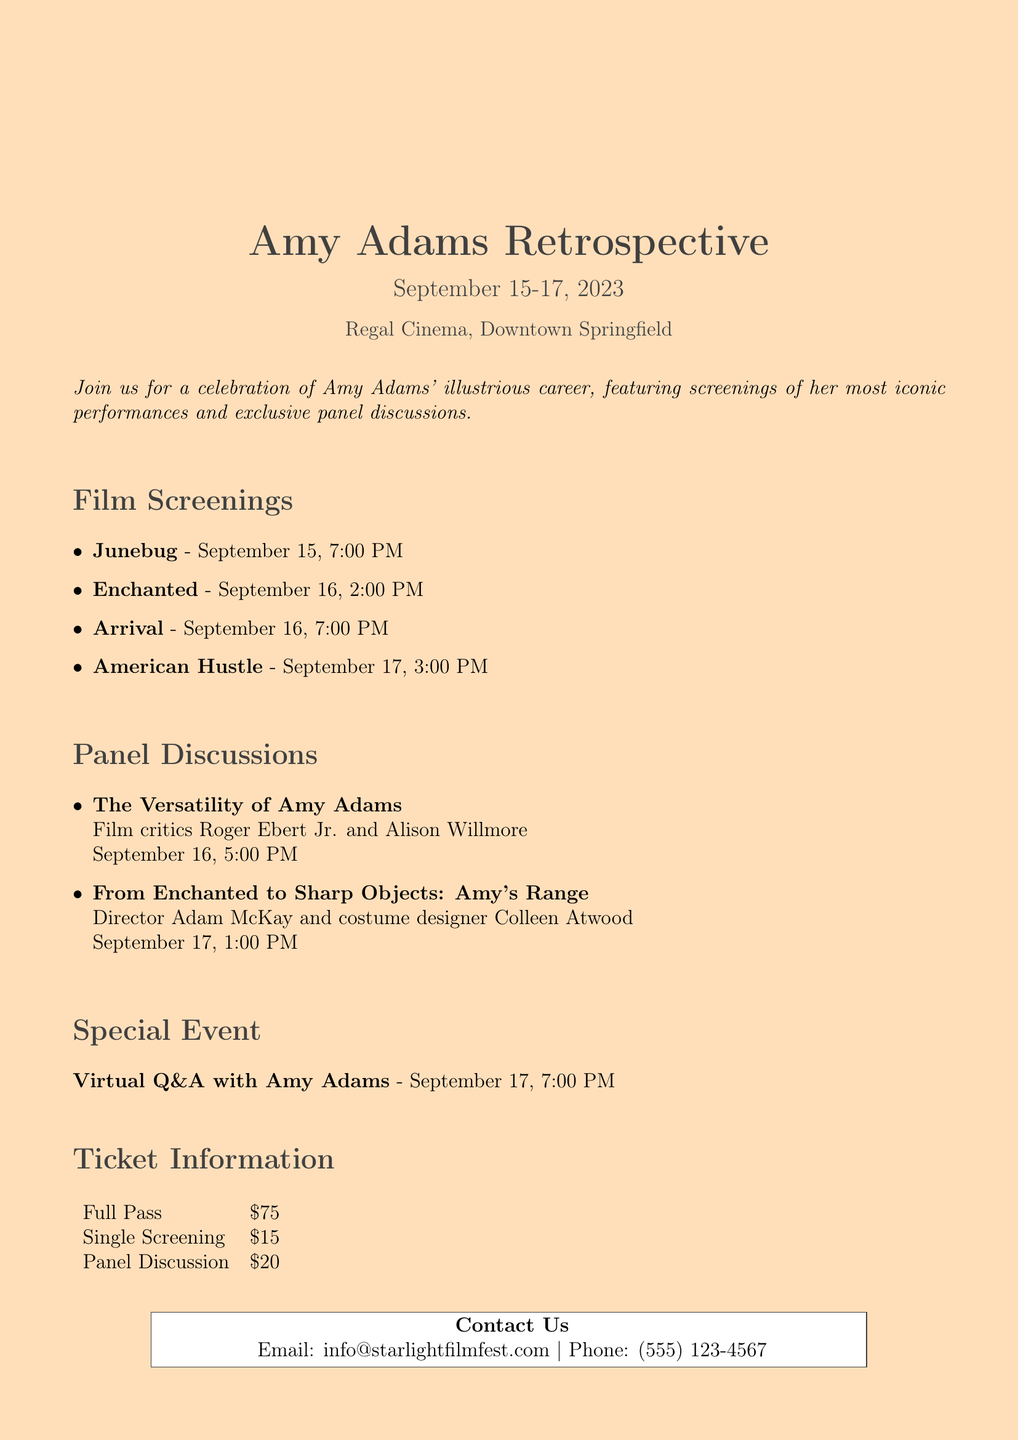What is the name of the event? The name of the event is mentioned at the beginning of the document as "Starlight Film Festival: Amy Adams Retrospective."
Answer: Starlight Film Festival: Amy Adams Retrospective What are the dates of the film festival? The dates of the film festival are clearly stated in the document as "September 15-17, 2023."
Answer: September 15-17, 2023 Where is the festival taking place? The document specifies the location as "Regal Cinema, Downtown Springfield."
Answer: Regal Cinema, Downtown Springfield What is the ticket price for a single screening? The document lists the ticket price for a single screening under the ticket information section as "$15."
Answer: $15 Who are the speakers for the panel discussion on September 16? The document provides the names of the speakers for that panel discussion as "Film critics Roger Ebert Jr. and Alison Willmore."
Answer: Film critics Roger Ebert Jr. and Alison Willmore What special event is happening on September 17? The document mentions a special event titled "Virtual Q&A with Amy Adams" scheduled for September 17.
Answer: Virtual Q&A with Amy Adams How many film screenings are scheduled for the festival? The document lists four film screenings under the film screenings section.
Answer: Four What is the total cost of a full pass? The document states the total cost for a full pass under ticket information as "$75."
Answer: $75 What time does the film "Arrival" start? The document specifies the start time for "Arrival" as "September 16, 7:00 PM."
Answer: September 16, 7:00 PM 